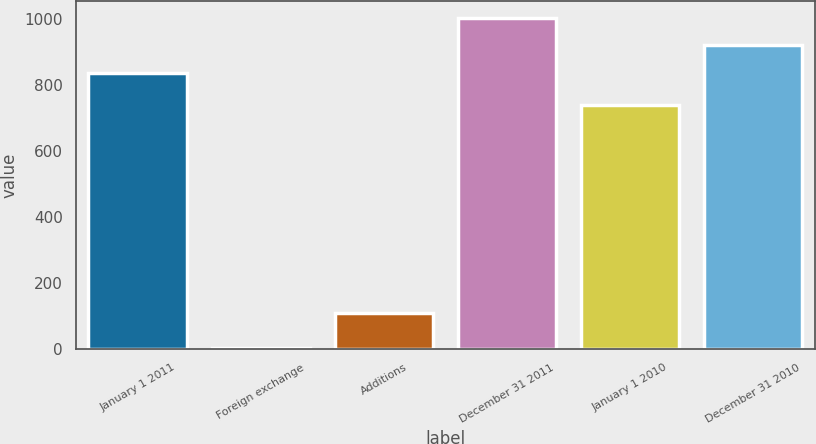<chart> <loc_0><loc_0><loc_500><loc_500><bar_chart><fcel>January 1 2011<fcel>Foreign exchange<fcel>Additions<fcel>December 31 2011<fcel>January 1 2010<fcel>December 31 2010<nl><fcel>835.4<fcel>4.8<fcel>110<fcel>1001.98<fcel>739.1<fcel>918.69<nl></chart> 